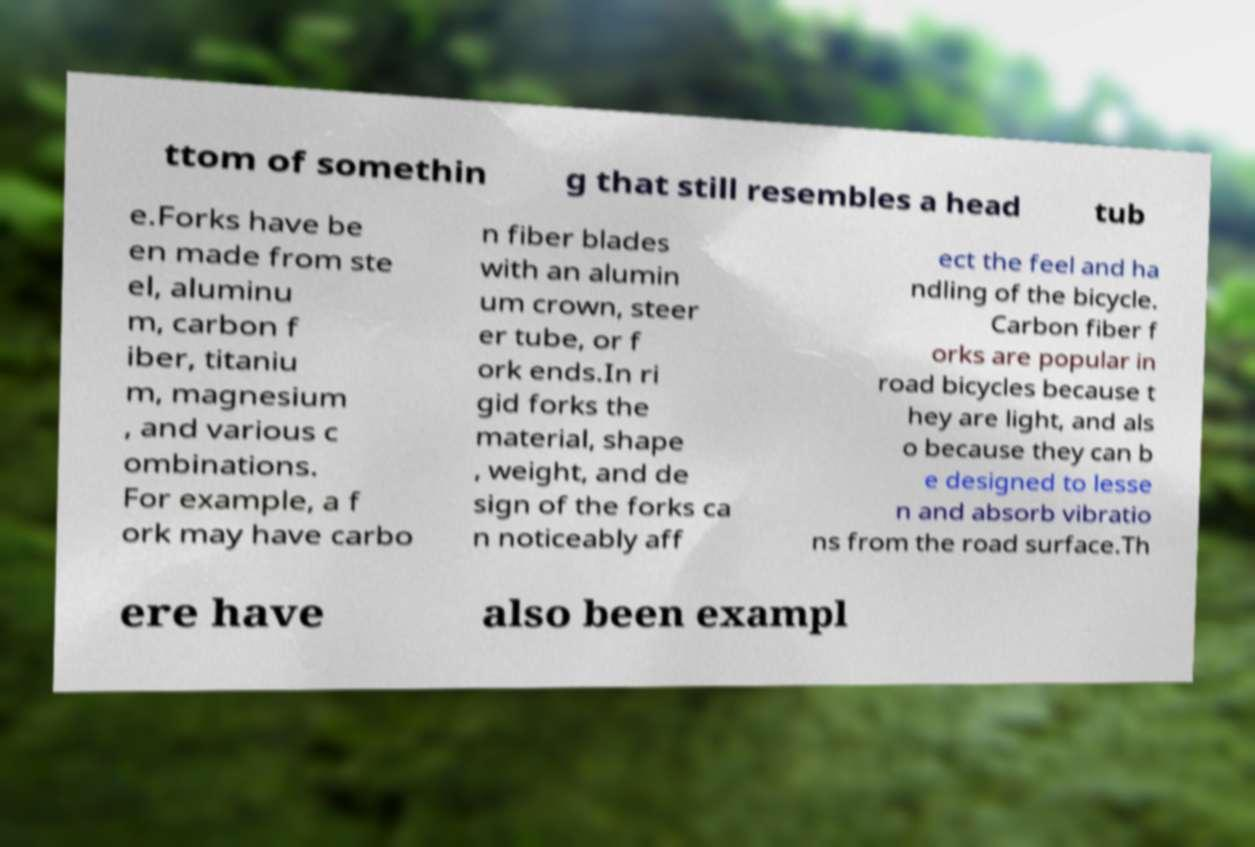Please read and relay the text visible in this image. What does it say? ttom of somethin g that still resembles a head tub e.Forks have be en made from ste el, aluminu m, carbon f iber, titaniu m, magnesium , and various c ombinations. For example, a f ork may have carbo n fiber blades with an alumin um crown, steer er tube, or f ork ends.In ri gid forks the material, shape , weight, and de sign of the forks ca n noticeably aff ect the feel and ha ndling of the bicycle. Carbon fiber f orks are popular in road bicycles because t hey are light, and als o because they can b e designed to lesse n and absorb vibratio ns from the road surface.Th ere have also been exampl 